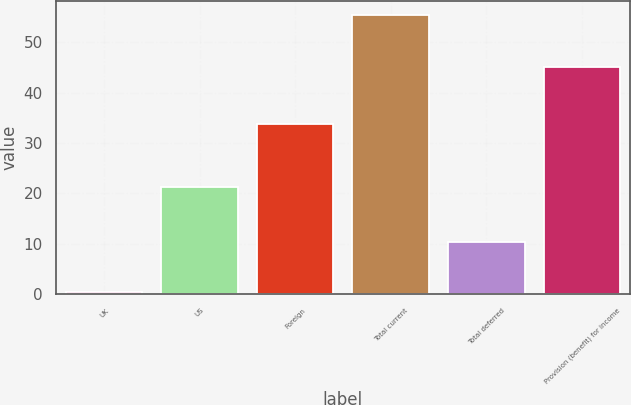<chart> <loc_0><loc_0><loc_500><loc_500><bar_chart><fcel>UK<fcel>US<fcel>Foreign<fcel>Total current<fcel>Total deferred<fcel>Provision (benefit) for income<nl><fcel>0.4<fcel>21.2<fcel>33.8<fcel>55.4<fcel>10.3<fcel>45.1<nl></chart> 